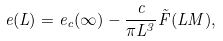Convert formula to latex. <formula><loc_0><loc_0><loc_500><loc_500>e ( L ) = e _ { c } ( \infty ) - \frac { c } { \pi L ^ { 3 } } \tilde { F } ( L M ) ,</formula> 